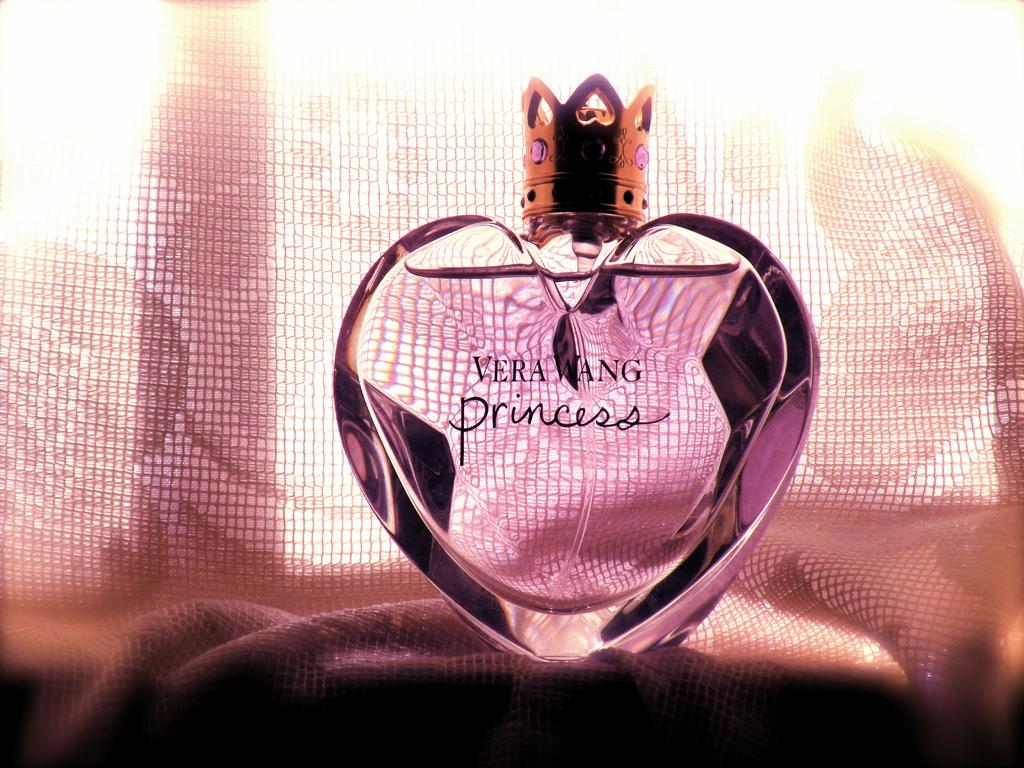<image>
Present a compact description of the photo's key features. A pink heart shaped bottle that says Vera Wang Princess on it. 